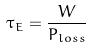<formula> <loc_0><loc_0><loc_500><loc_500>\tau _ { E } = \frac { W } { P _ { l o s s } }</formula> 